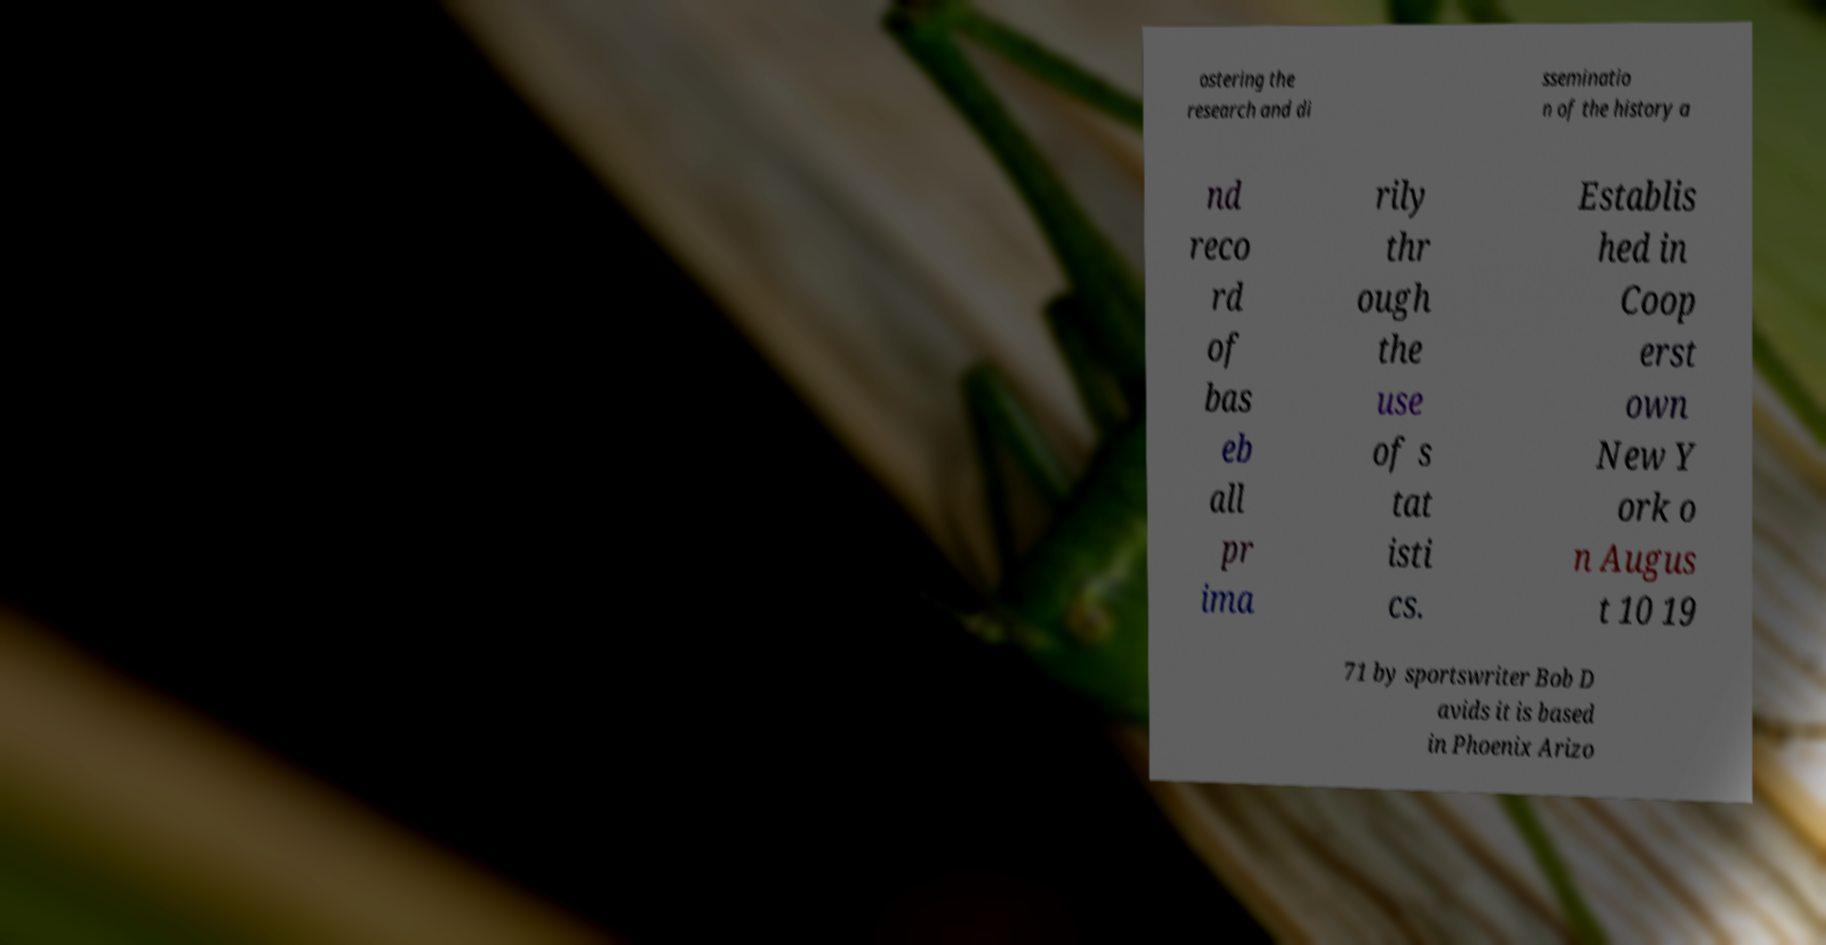Could you assist in decoding the text presented in this image and type it out clearly? ostering the research and di sseminatio n of the history a nd reco rd of bas eb all pr ima rily thr ough the use of s tat isti cs. Establis hed in Coop erst own New Y ork o n Augus t 10 19 71 by sportswriter Bob D avids it is based in Phoenix Arizo 